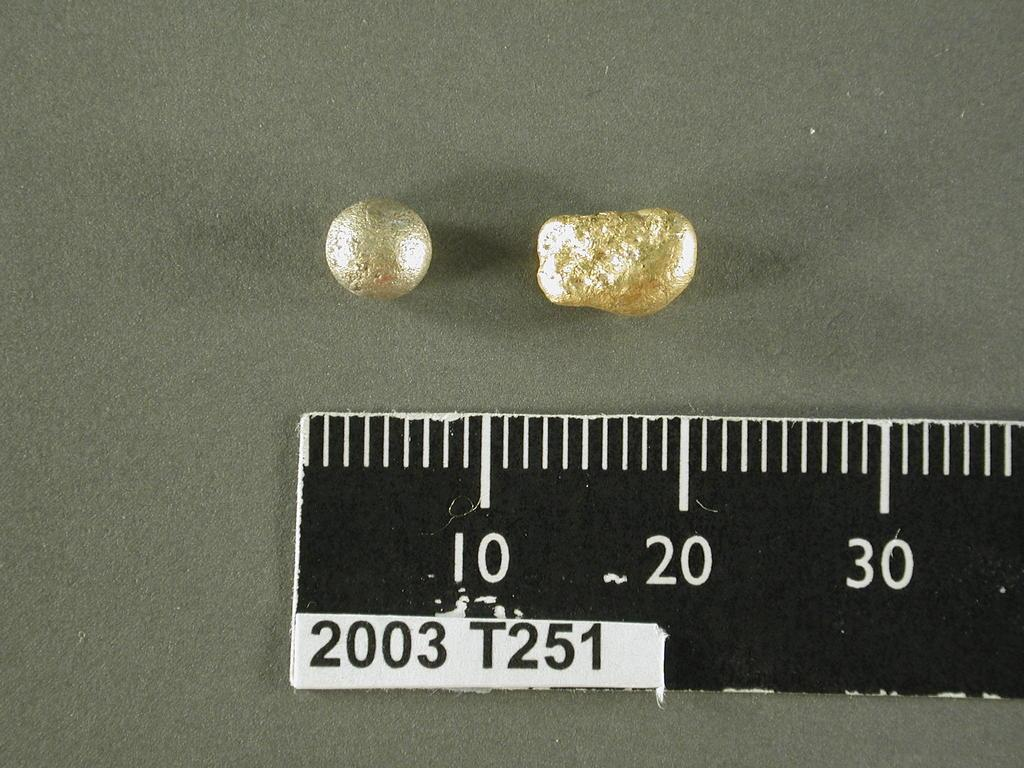Provide a one-sentence caption for the provided image. a few pearly beads with part of a ruler by them that says 10 and 20. 